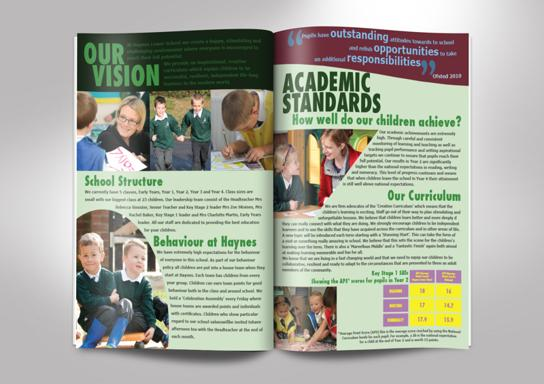What specific programs are highlighted in the 'Our Curriculum' section visible in the image? The 'Our Curriculum' section in the image outlines various academic subjects offered at Haynes, with a vivid depiction of their performance statistics in the form of graphs and charts. It mentions tailored programs fitting diverse student needs and interests, focusing on a balanced and comprehensive educational approach. 